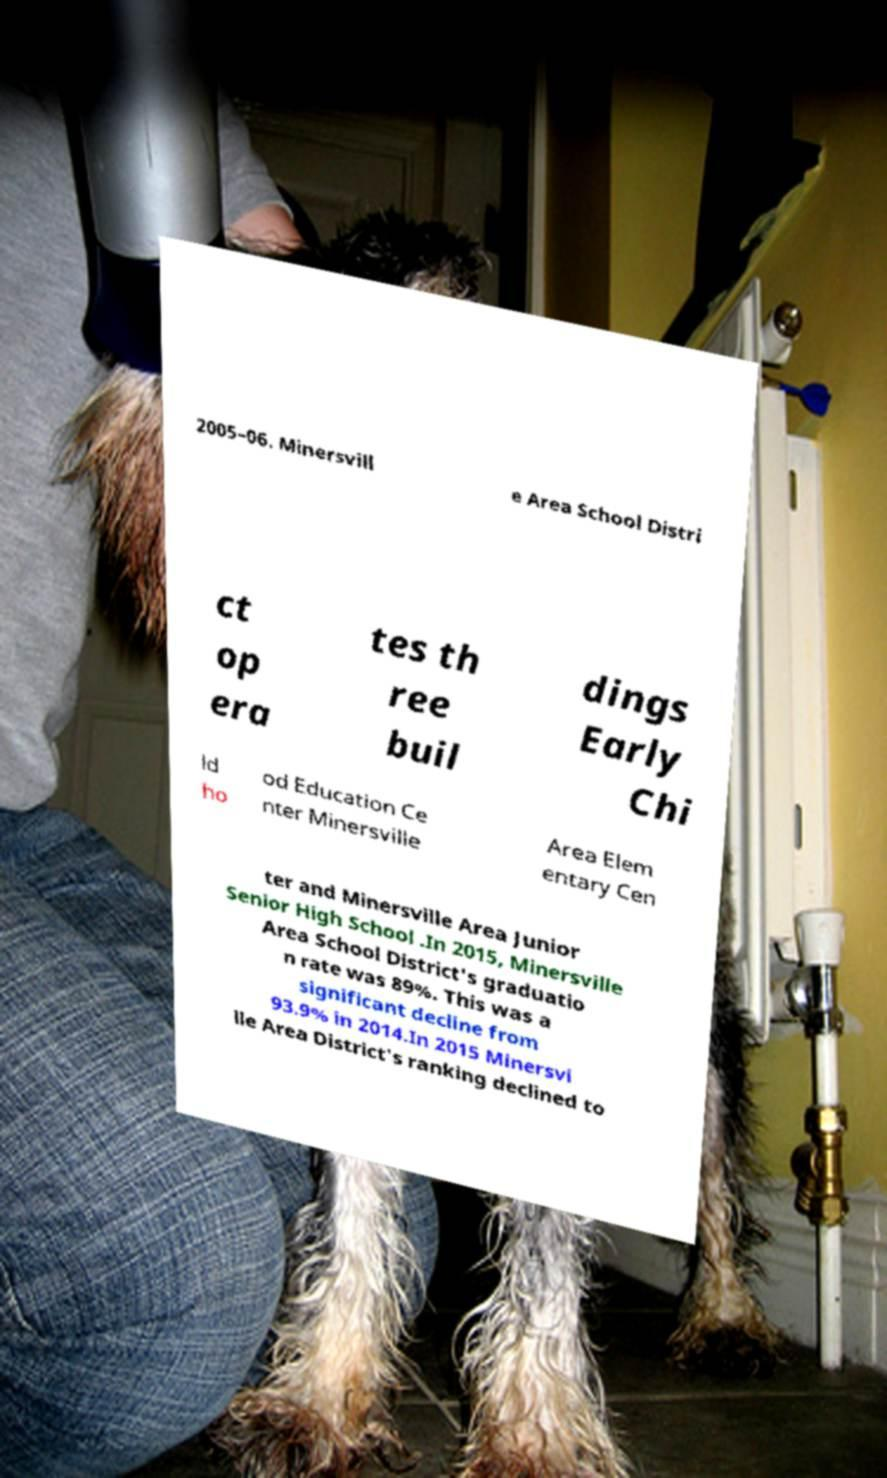Could you extract and type out the text from this image? 2005–06. Minersvill e Area School Distri ct op era tes th ree buil dings Early Chi ld ho od Education Ce nter Minersville Area Elem entary Cen ter and Minersville Area Junior Senior High School .In 2015, Minersville Area School District's graduatio n rate was 89%. This was a significant decline from 93.9% in 2014.In 2015 Minersvi lle Area District's ranking declined to 